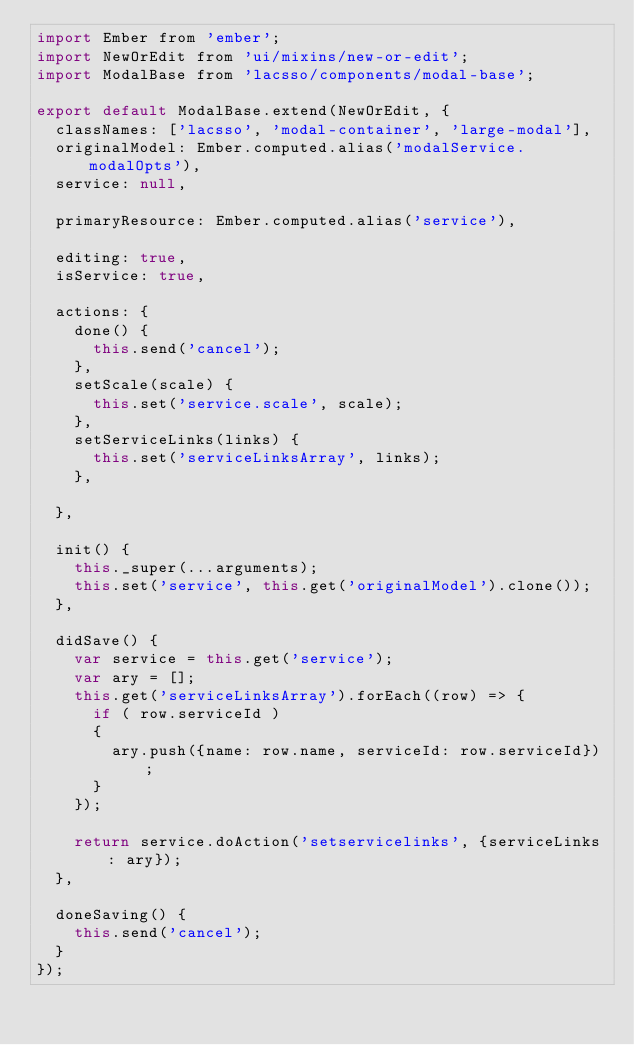Convert code to text. <code><loc_0><loc_0><loc_500><loc_500><_JavaScript_>import Ember from 'ember';
import NewOrEdit from 'ui/mixins/new-or-edit';
import ModalBase from 'lacsso/components/modal-base';

export default ModalBase.extend(NewOrEdit, {
  classNames: ['lacsso', 'modal-container', 'large-modal'],
  originalModel: Ember.computed.alias('modalService.modalOpts'),
  service: null,

  primaryResource: Ember.computed.alias('service'),

  editing: true,
  isService: true,

  actions: {
    done() {
      this.send('cancel');
    },
    setScale(scale) {
      this.set('service.scale', scale);
    },
    setServiceLinks(links) {
      this.set('serviceLinksArray', links);
    },

  },

  init() {
    this._super(...arguments);
    this.set('service', this.get('originalModel').clone());
  },

  didSave() {
    var service = this.get('service');
    var ary = [];
    this.get('serviceLinksArray').forEach((row) => {
      if ( row.serviceId )
      {
        ary.push({name: row.name, serviceId: row.serviceId});
      }
    });

    return service.doAction('setservicelinks', {serviceLinks: ary});
  },

  doneSaving() {
    this.send('cancel');
  }
});
</code> 